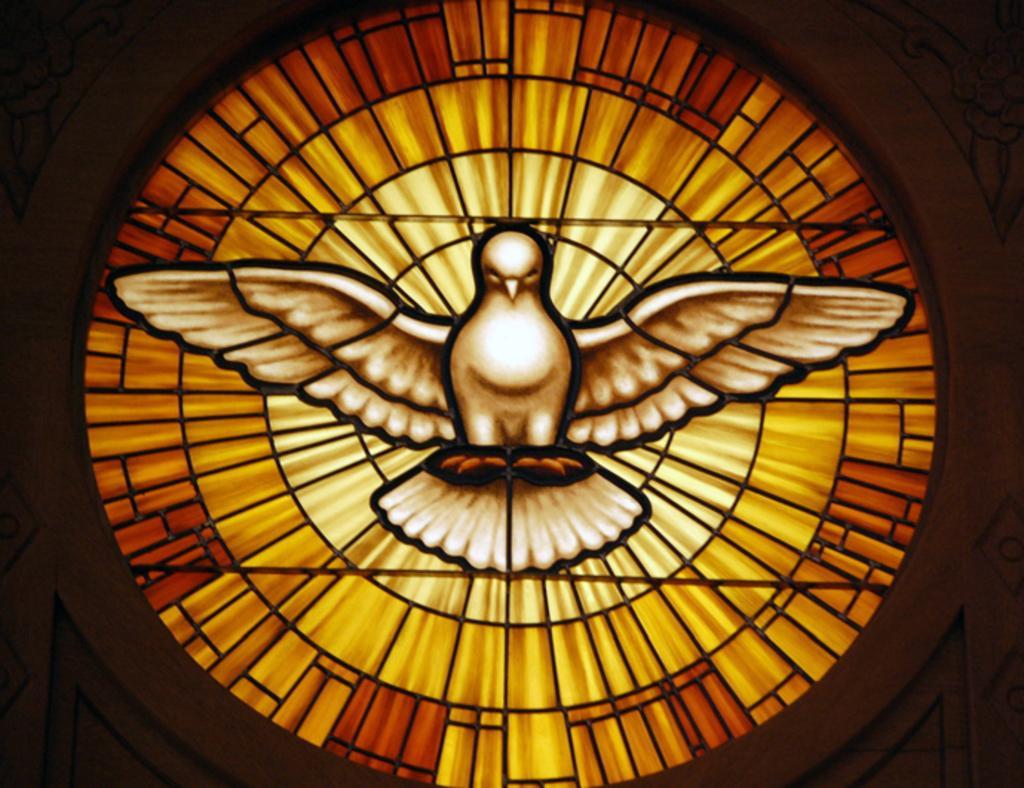How would you summarize this image in a sentence or two? In this picture there is a image of a bird which is in white color and there are some other objects beside it. 